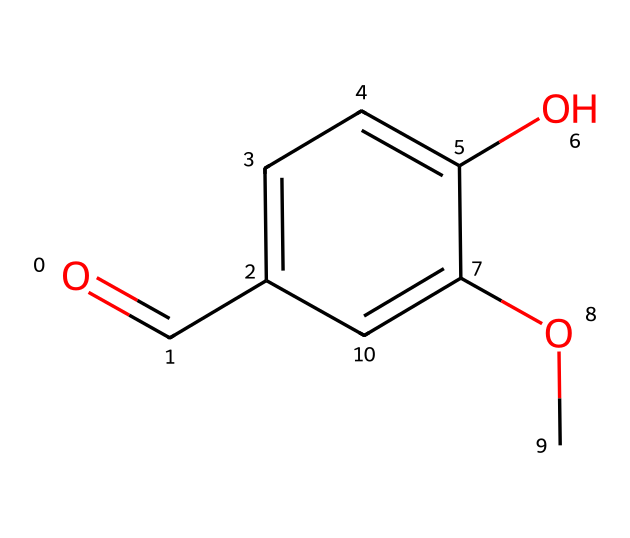What is the molecular formula of vanillin? By examining the SMILES representation, we can identify the individual elements present. In this case, there are 8 carbon (C) atoms, 8 hydrogen (H) atoms, and 3 oxygen (O) atoms. Therefore, the molecular formula can be constructed as C8H8O3.
Answer: C8H8O3 How many hydroxyl (OH) groups are in the chemical structure? By looking into the structure, oxygens that are connected to a carbon or standing alone typically indicate hydroxyl groups. In this case, there are two hydroxyl groups associated with the aromatic ring.
Answer: 2 Is the chemical structure of vanillin symmetrical? When analyzing the structure, the placement of the functional groups (hydroxyl and methoxy) on the aromatic ring indicates that the compound lacks symmetry. As they are located at different positions, vanillin can be classified as asymmetrical.
Answer: No What type of functional group is present on the aromatic ring of vanillin? The presence of -OH and -OCH3 groups attached to the benzene ring indicates functional groups. The -OH indicates a phenolic group and the -OCH3 indicates a methoxy group. Both signify that vanillin is a phenolic compound.
Answer: Phenolic What property does the carbonyl group contribute to vanillin? The carbonyl group (C=O) in the chemical structure plays a crucial role in defining the reactivity and flavor profile of the compound. It is responsible for the compound's aromatic properties, enhancing its sweet flavor profile.
Answer: Aromatic What type of aromatic compound is vanillin classified as? Vanillin is identified as a phenolic compound due to the presence of a hydroxyl (-OH) group bonded to the aromatic carbon structure, making it a derivative of a phenol.
Answer: Phenolic How does the methoxy group affect vanillin's properties? The methoxy group (–OCH3) in the structure contributes to the compound’s overall stability and flavor profile. It affects its solubility and aromatic characteristics, enhancing its sweet aroma, which is essential in scone flavoring.
Answer: Enhances sweetness 